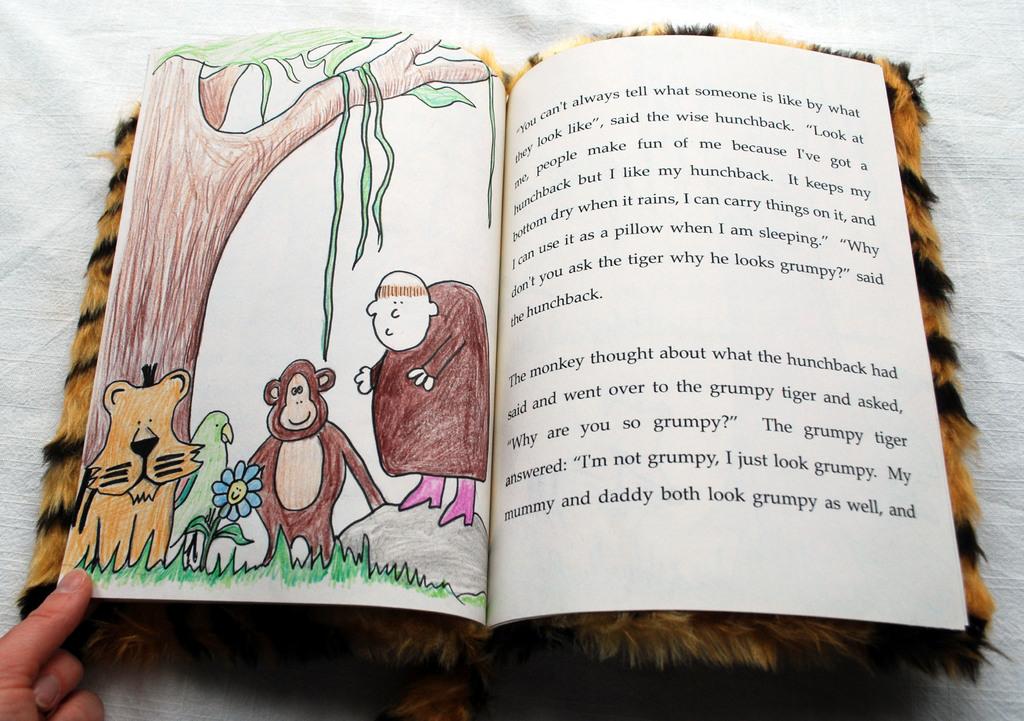Is the book written for children?
Your response must be concise. Yes. What are the last 3 words on the page?
Your response must be concise. As well and. 